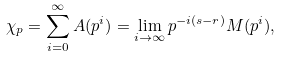<formula> <loc_0><loc_0><loc_500><loc_500>\chi _ { p } = \sum _ { i = 0 } ^ { \infty } A ( p ^ { i } ) = \lim _ { i \to \infty } p ^ { - i ( s - r ) } M ( p ^ { i } ) ,</formula> 